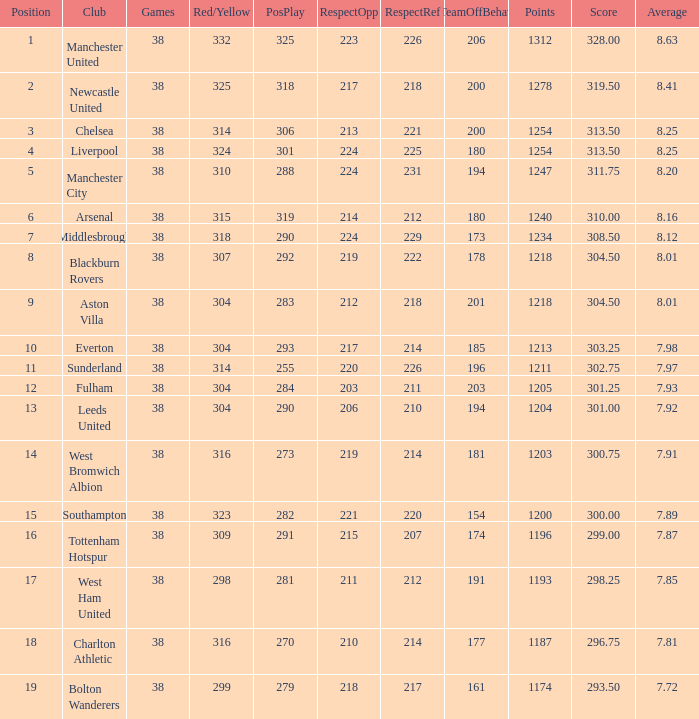Name the points for 212 respect toward opponents 1218.0. 